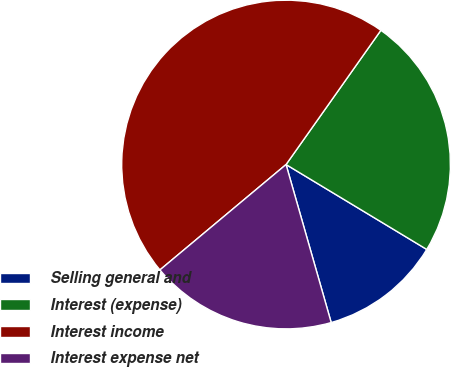Convert chart. <chart><loc_0><loc_0><loc_500><loc_500><pie_chart><fcel>Selling general and<fcel>Interest (expense)<fcel>Interest income<fcel>Interest expense net<nl><fcel>11.93%<fcel>23.85%<fcel>45.87%<fcel>18.35%<nl></chart> 